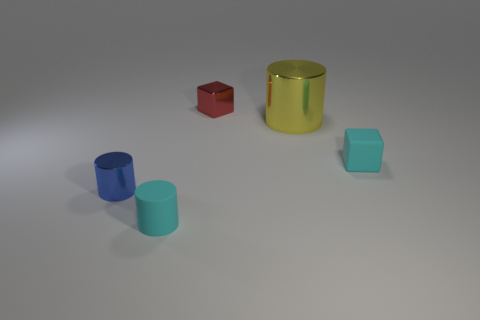Is there any other thing that has the same size as the yellow cylinder?
Give a very brief answer. No. There is a tiny object right of the red metallic cube; does it have the same shape as the matte thing left of the small metallic cube?
Your answer should be compact. No. What is the size of the cyan rubber cube?
Give a very brief answer. Small. There is a tiny cube left of the small cyan matte object to the right of the red metallic thing behind the blue object; what is it made of?
Your answer should be very brief. Metal. What number of other objects are the same color as the small shiny cube?
Your answer should be compact. 0. How many red things are small cubes or matte cubes?
Keep it short and to the point. 1. There is a cyan thing that is to the left of the tiny red block; what is its material?
Give a very brief answer. Rubber. Are the cyan thing on the right side of the red metal block and the tiny cyan cylinder made of the same material?
Ensure brevity in your answer.  Yes. The tiny blue thing is what shape?
Your response must be concise. Cylinder. How many yellow things are behind the tiny cyan thing behind the tiny rubber thing in front of the small blue object?
Offer a terse response. 1. 